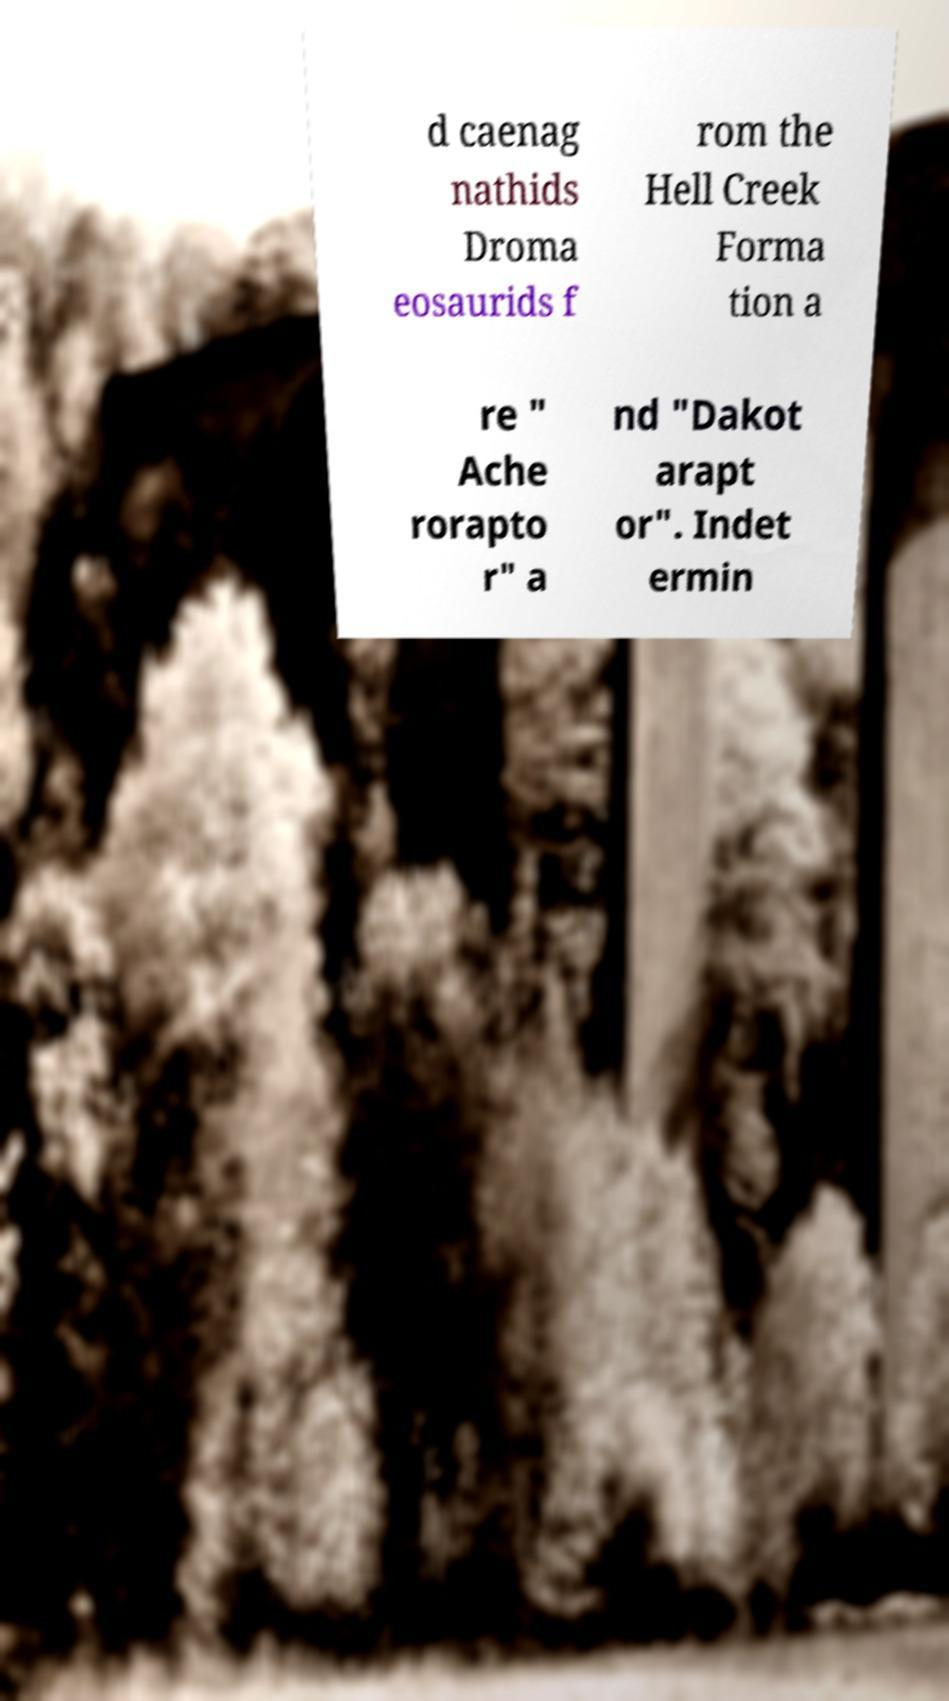Could you assist in decoding the text presented in this image and type it out clearly? d caenag nathids Droma eosaurids f rom the Hell Creek Forma tion a re " Ache rorapto r" a nd "Dakot arapt or". Indet ermin 